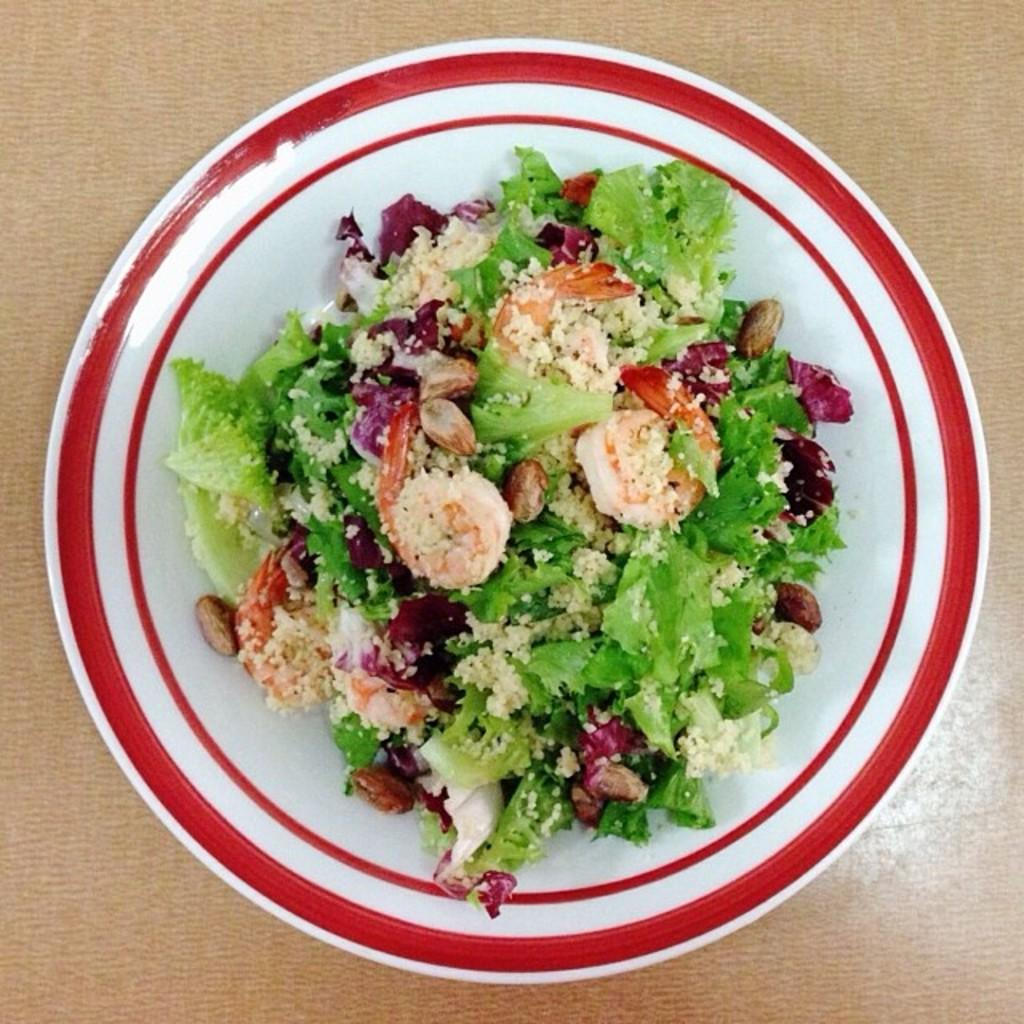What can be seen on the serving plate in the image? There is food on the serving plate in the image. Can you describe the food on the serving plate? Unfortunately, the specific type of food cannot be determined from the provided facts. How many baseballs are on the serving plate in the image? There are no baseballs present on the serving plate in the image. 